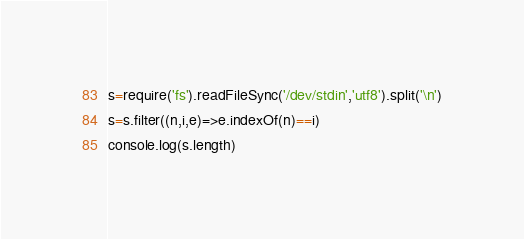<code> <loc_0><loc_0><loc_500><loc_500><_TypeScript_>s=require('fs').readFileSync('/dev/stdin','utf8').split('\n')
s=s.filter((n,i,e)=>e.indexOf(n)==i)
console.log(s.length)</code> 